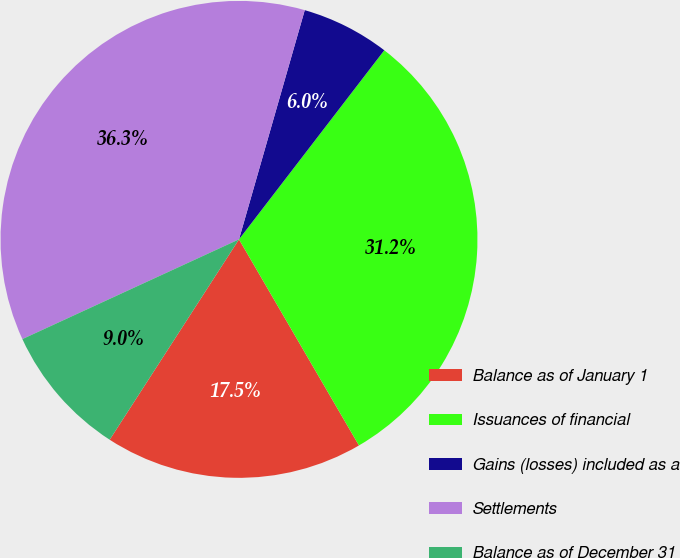Convert chart to OTSL. <chart><loc_0><loc_0><loc_500><loc_500><pie_chart><fcel>Balance as of January 1<fcel>Issuances of financial<fcel>Gains (losses) included as a<fcel>Settlements<fcel>Balance as of December 31<nl><fcel>17.51%<fcel>31.18%<fcel>5.98%<fcel>36.31%<fcel>9.01%<nl></chart> 